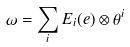<formula> <loc_0><loc_0><loc_500><loc_500>\omega = \sum _ { i } E _ { i } ( e ) \otimes \theta ^ { i }</formula> 